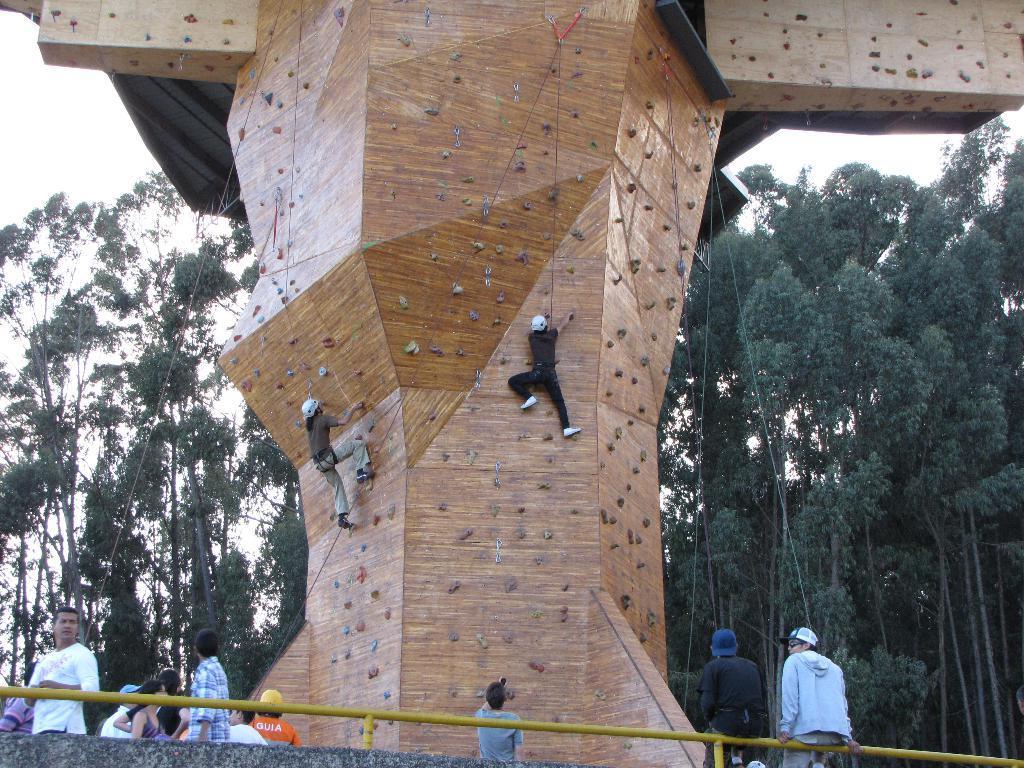Could you give a brief overview of what you see in this image? In this image there are group of persons standing, sitting and climbing. In the background there are trees. 